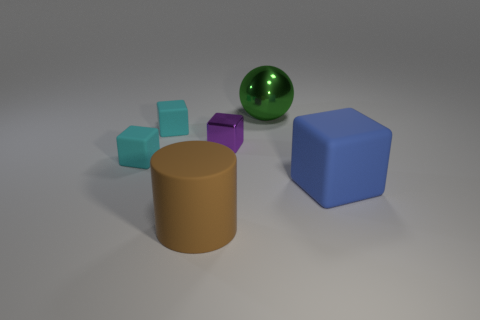What color is the cylinder that is the same size as the green ball? The cylinder shares its size with the green ball and boasts a rich, earthy brown color that stands out distinctly among the various shapes. 